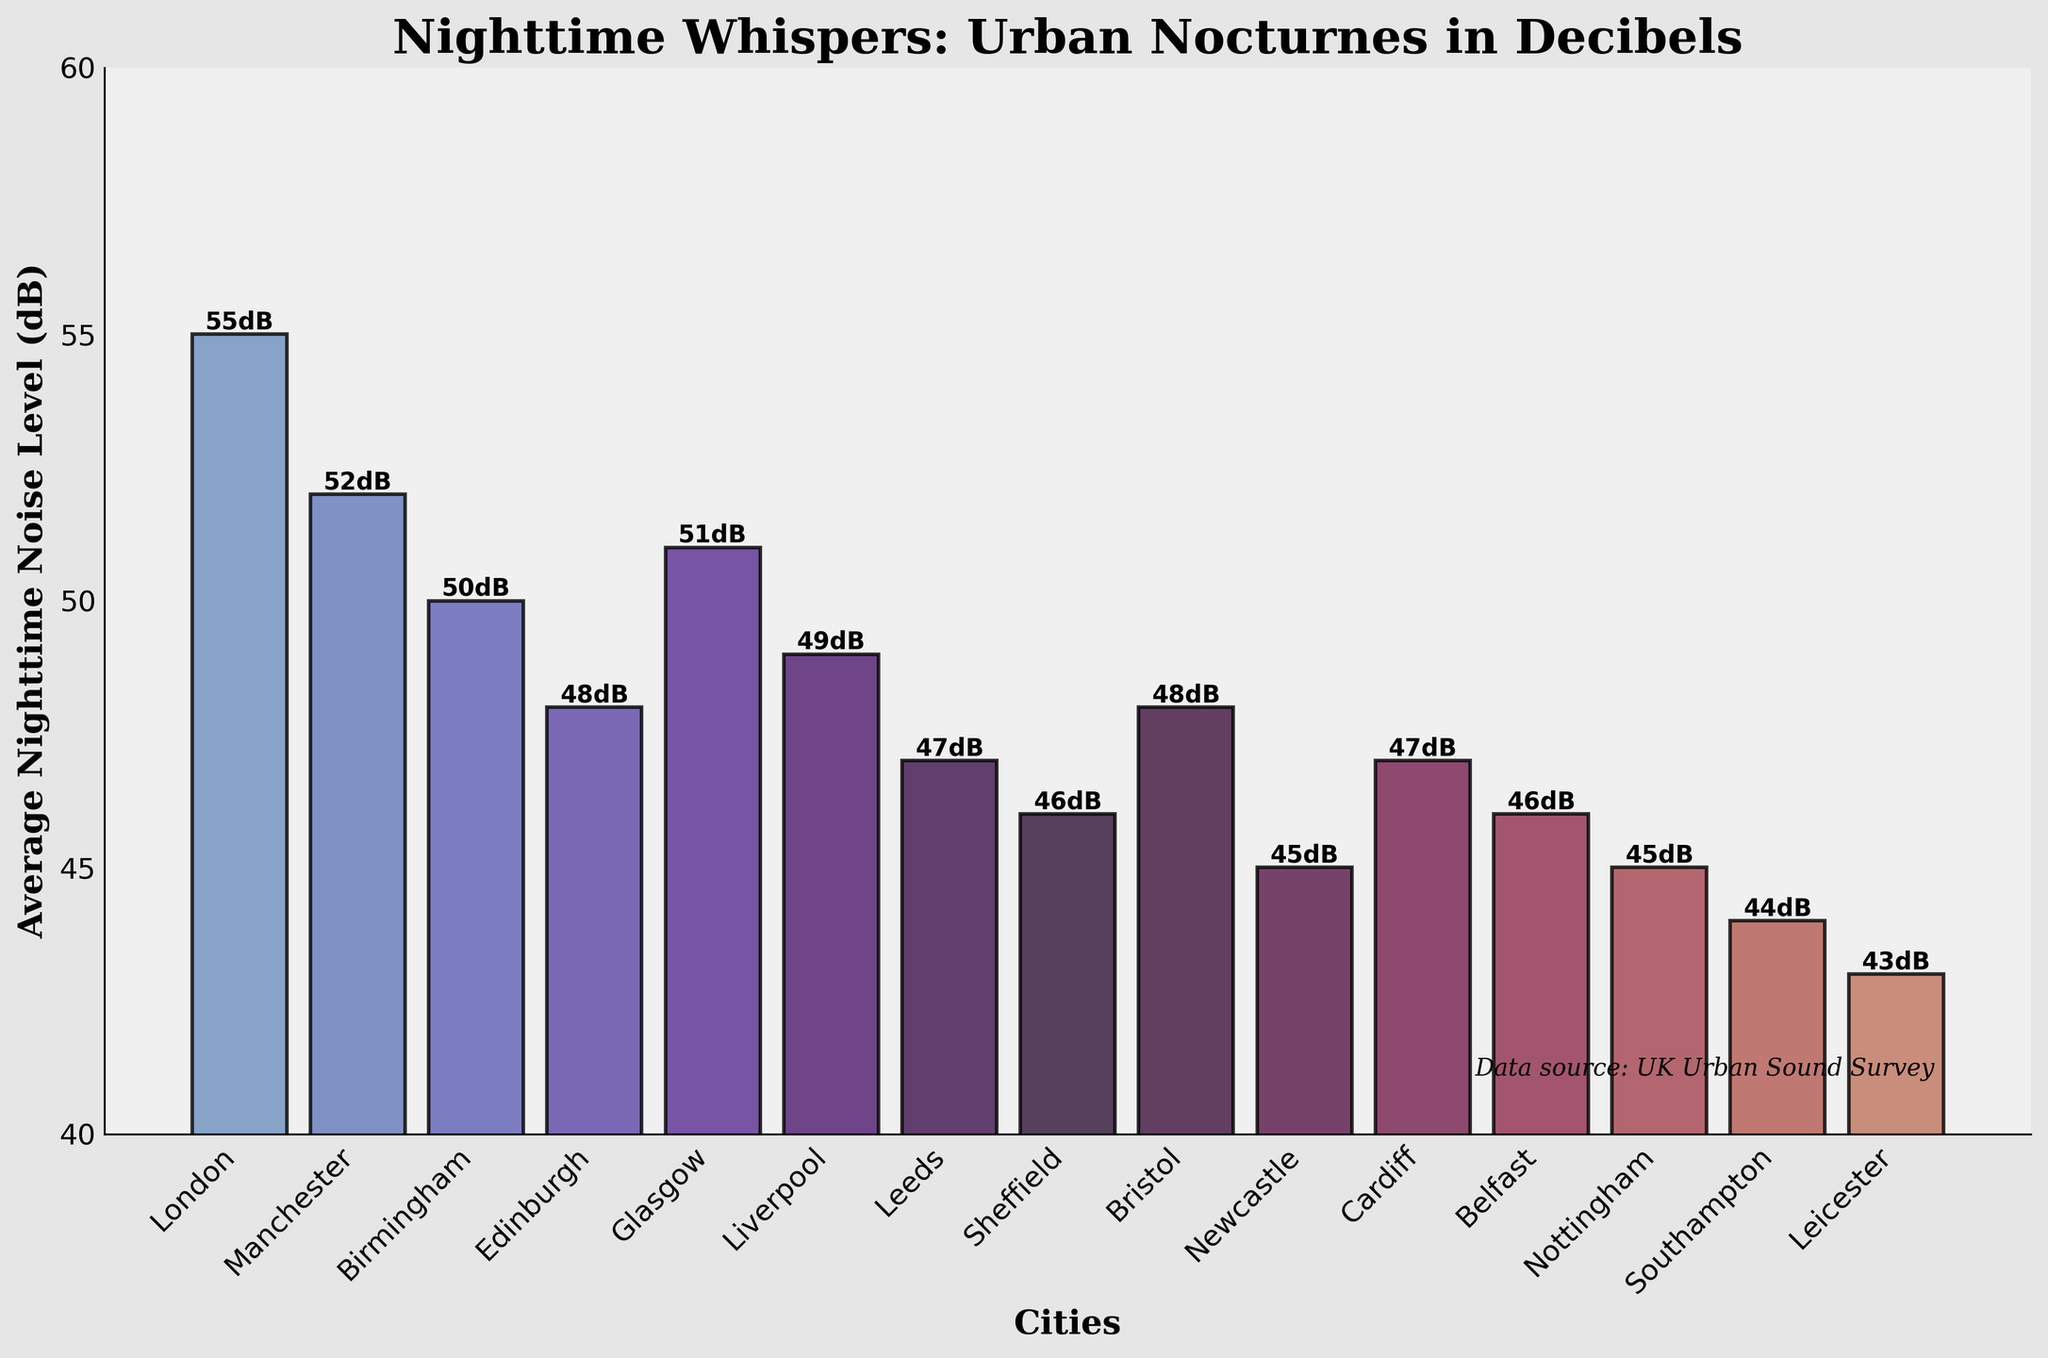What's the city with the highest nighttime noise level? The bar chart shows that the city with the highest bar (and labeled as 55dB) is London.
Answer: London Which cities have nighttime noise levels below 50 dB? The chart indicates that Sheffield (46dB), Leeds (47dB), Bristol (48dB), Edinburgh (48dB), Liverpool (49dB), Cardiff (47dB), Belfast (46dB), Newcastle (45dB), Southampton (44dB), and Leicester (43dB) have bars below 50 dB.
Answer: Sheffield, Leeds, Bristol, Edinburgh, Liverpool, Cardiff, Belfast, Newcastle, Southampton, Leicester How much higher is the nighttime noise level in London compared to Leicester? The chart shows London at 55dB and Leicester at 43dB. The difference is calculated as 55 - 43.
Answer: 12dB What is the average nighttime noise level across all cities? Sum all the given noise levels (55 + 52 + 50 + 48 + 51 + 49 + 47 + 46 + 48 + 45 + 47 + 46 + 45 + 44 + 43 = 716) and divide by the number of cities (15).
Answer: 47.73dB Which city has the lowest nighttime noise level? According to the chart, the city with the smallest bar (and labeled as 43dB) is Leicester.
Answer: Leicester Compare the nighttime noise levels of Manchester and Glasgow. Which is higher and by how much? Manchester is at 52dB while Glasgow is at 51dB. The difference is 52 - 51.
Answer: Manchester, 1dB What is the combined nighttime noise level of Edinburgh and Bristol? Both cities have nighttime noise levels of 48dB each. The combined level is 48 + 48.
Answer: 96dB Is there a significant difference in nighttime noise levels between Newcastle and Nottingham? Newcastle has a noise level of 45dB, and Nottingham also has 45dB. Thus, their difference is 45 - 45.
Answer: No, 0dB 